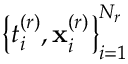<formula> <loc_0><loc_0><loc_500><loc_500>\left \{ { t } _ { i } ^ { ( r ) } , { x } _ { i } ^ { ( r ) } \right \} _ { i = 1 } ^ { N _ { r } }</formula> 